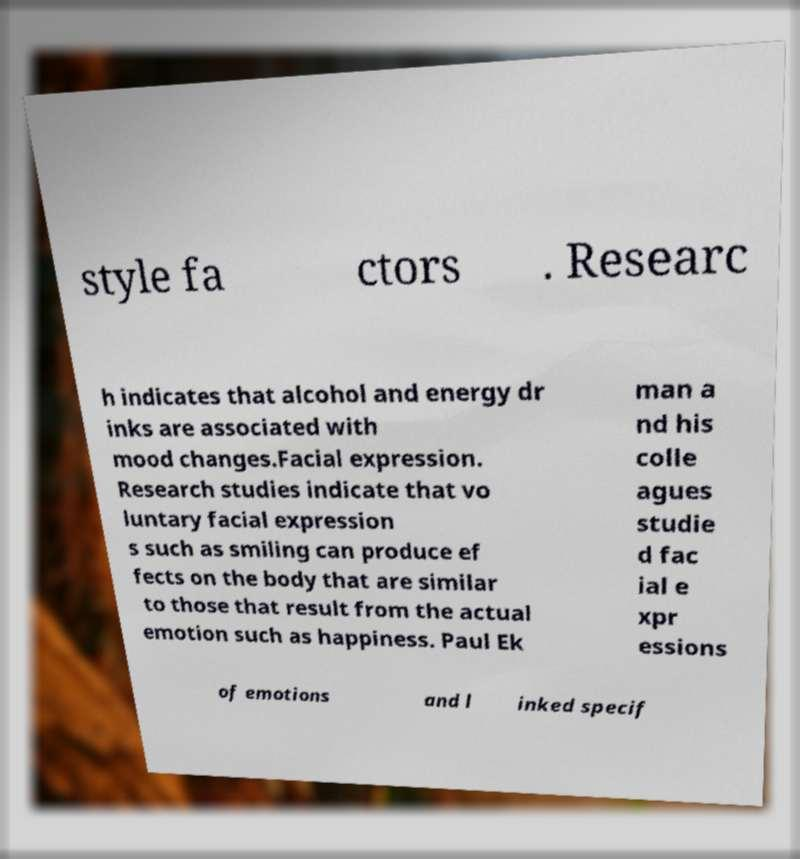For documentation purposes, I need the text within this image transcribed. Could you provide that? style fa ctors . Researc h indicates that alcohol and energy dr inks are associated with mood changes.Facial expression. Research studies indicate that vo luntary facial expression s such as smiling can produce ef fects on the body that are similar to those that result from the actual emotion such as happiness. Paul Ek man a nd his colle agues studie d fac ial e xpr essions of emotions and l inked specif 